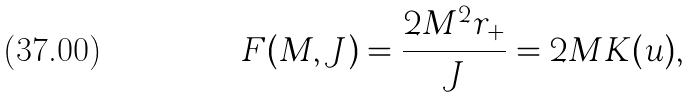<formula> <loc_0><loc_0><loc_500><loc_500>F ( M , J ) = \frac { 2 M ^ { 2 } r _ { + } } { J } = 2 M K ( u ) ,</formula> 